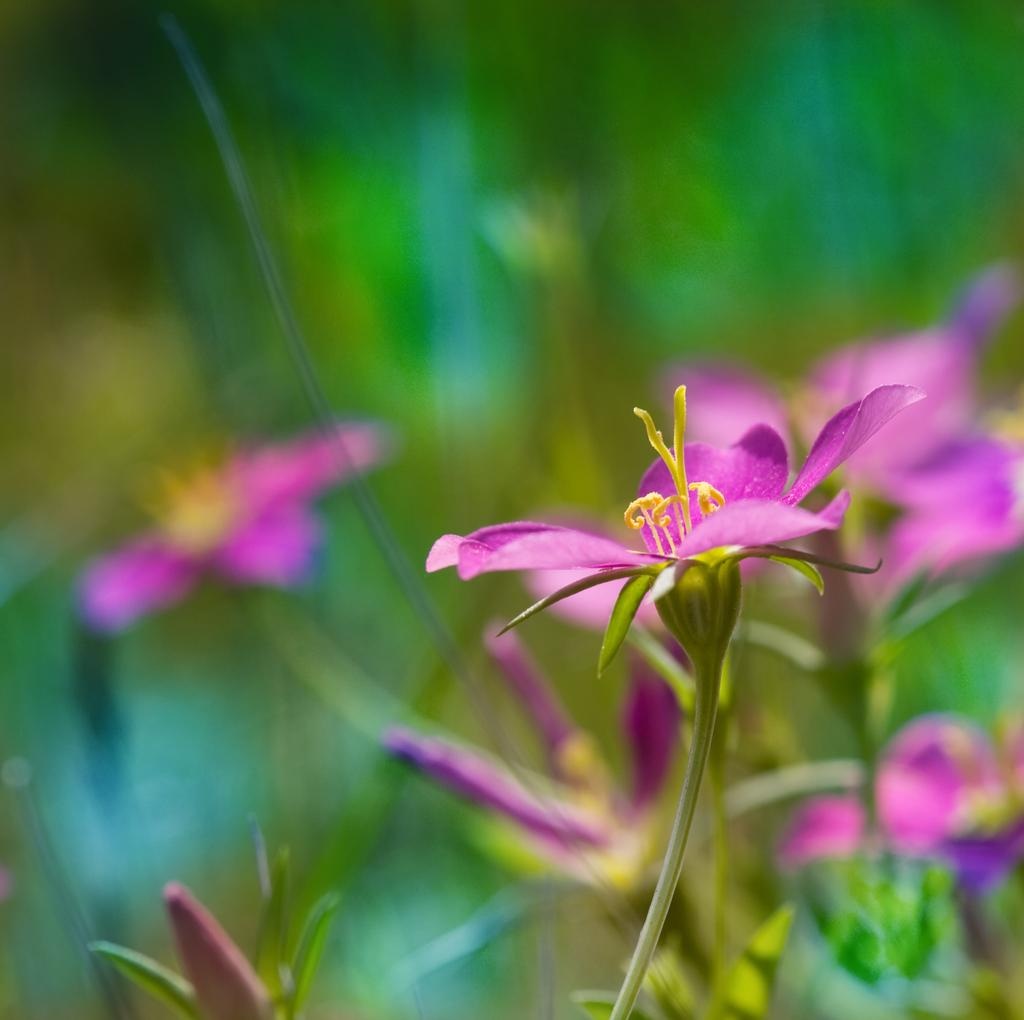What is the main subject of the image? The main subject of the image is a group of flowers. Are there any other elements related to the flowers in the image? Yes, there are leaves in the image. What type of lace can be seen on the flowers in the image? There is no lace present on the flowers in the image. How does the steam affect the appearance of the flowers in the image? There is no steam present in the image, so it cannot affect the appearance of the flowers. 